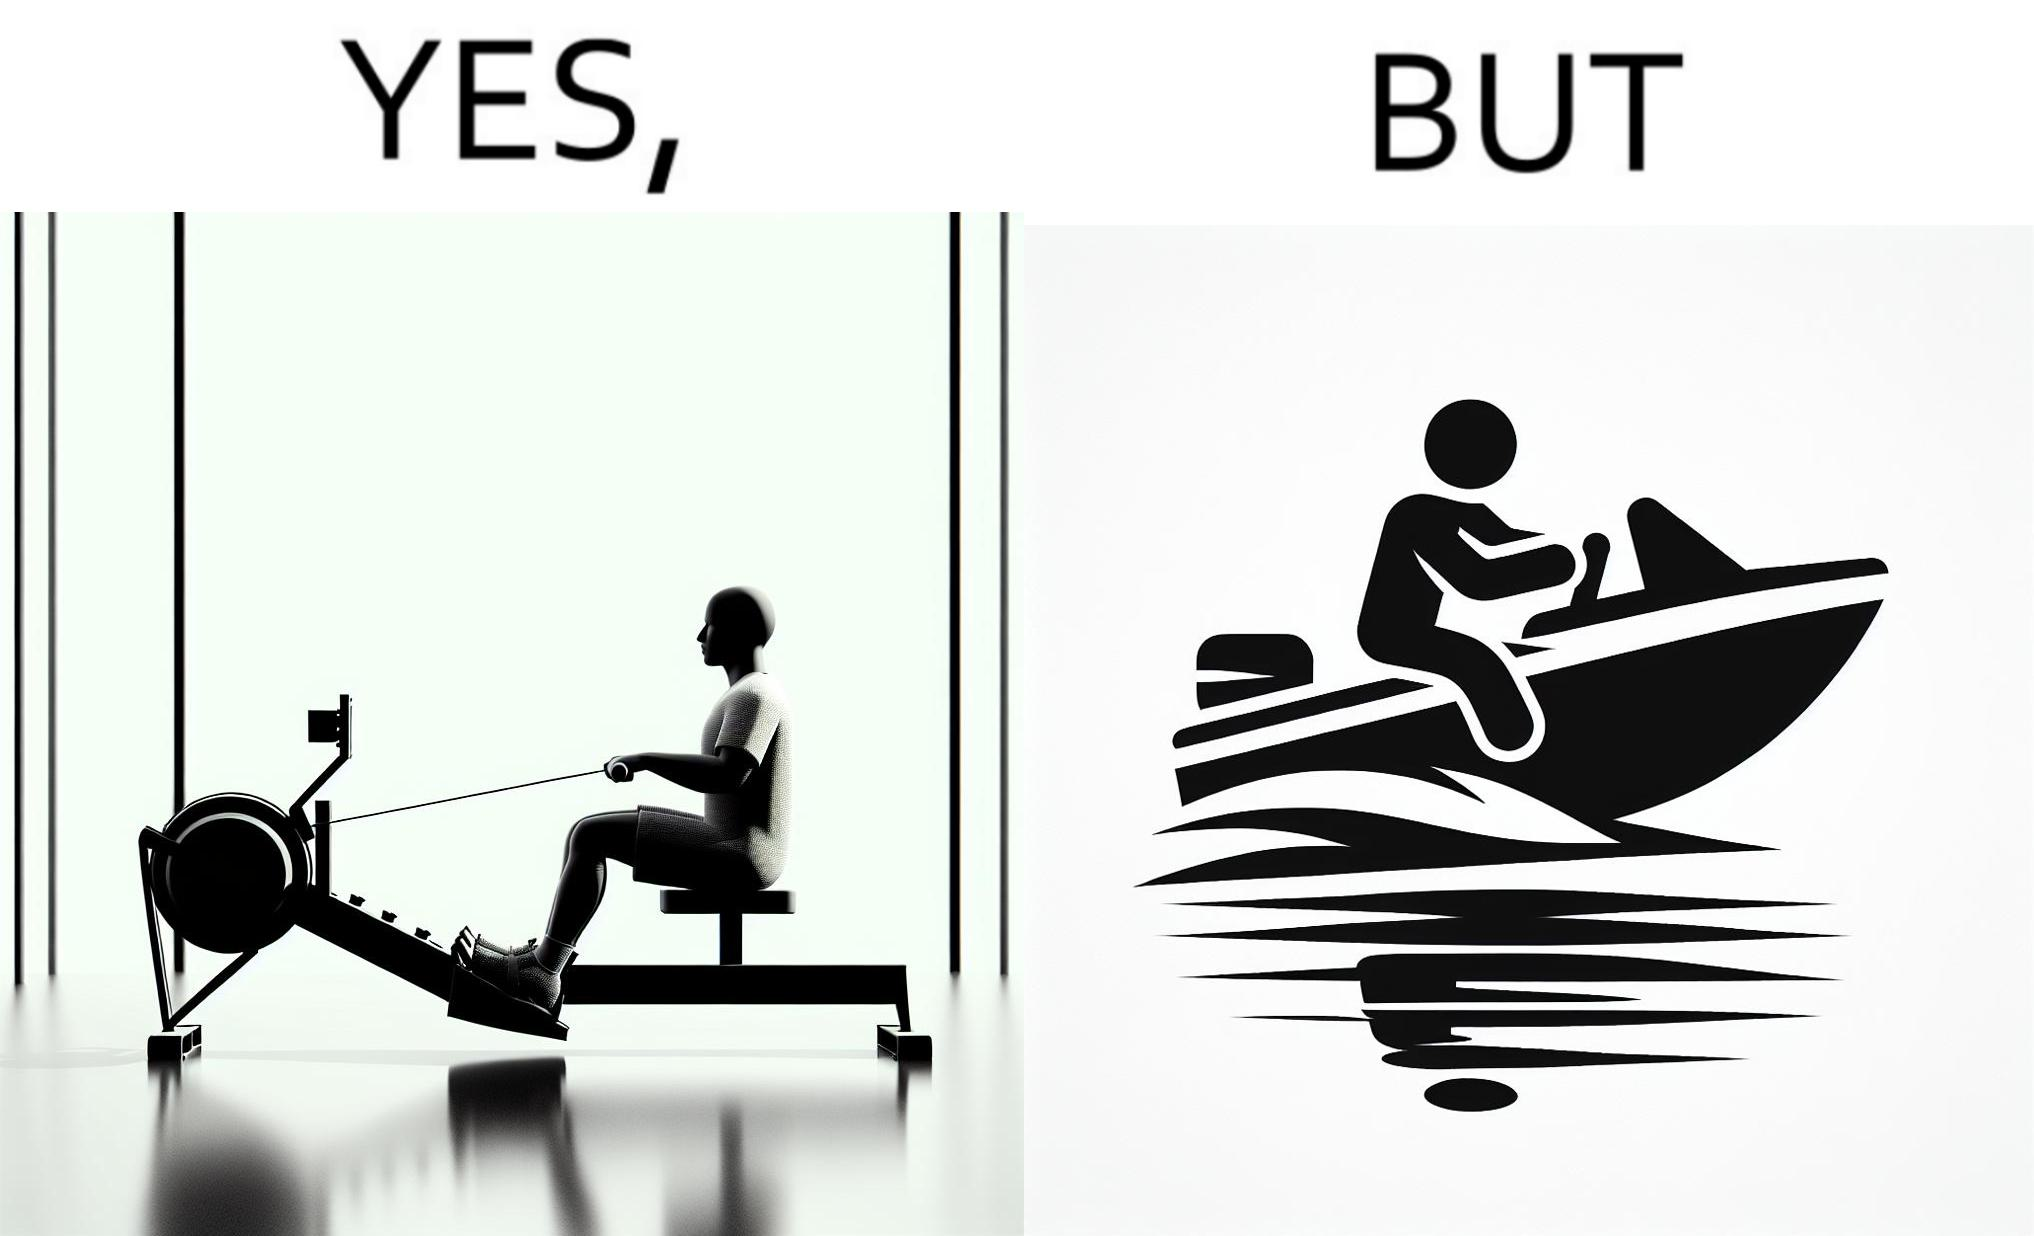Provide a description of this image. The image is ironic, because people often use rowing machine at the gym don't prefer rowing when it comes to boats 